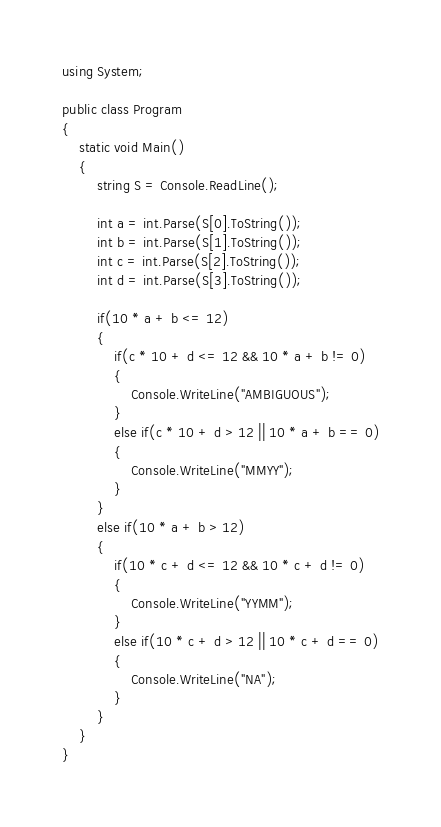Convert code to text. <code><loc_0><loc_0><loc_500><loc_500><_C#_>using System;

public class Program
{
    static void Main()
    {
        string S = Console.ReadLine();

        int a = int.Parse(S[0].ToString());
        int b = int.Parse(S[1].ToString());
        int c = int.Parse(S[2].ToString());
        int d = int.Parse(S[3].ToString());

        if(10 * a + b <= 12)
        {
            if(c * 10 + d <= 12 && 10 * a + b != 0)
            {
                Console.WriteLine("AMBIGUOUS");
            }
            else if(c * 10 + d > 12 || 10 * a + b == 0)
            {
                Console.WriteLine("MMYY");
            }
        }
        else if(10 * a + b > 12)
        {
            if(10 * c + d <= 12 && 10 * c + d != 0)
            {
                Console.WriteLine("YYMM");
            }
            else if(10 * c + d > 12 || 10 * c + d == 0)
            {
                Console.WriteLine("NA");
            }
        }
    }
}</code> 